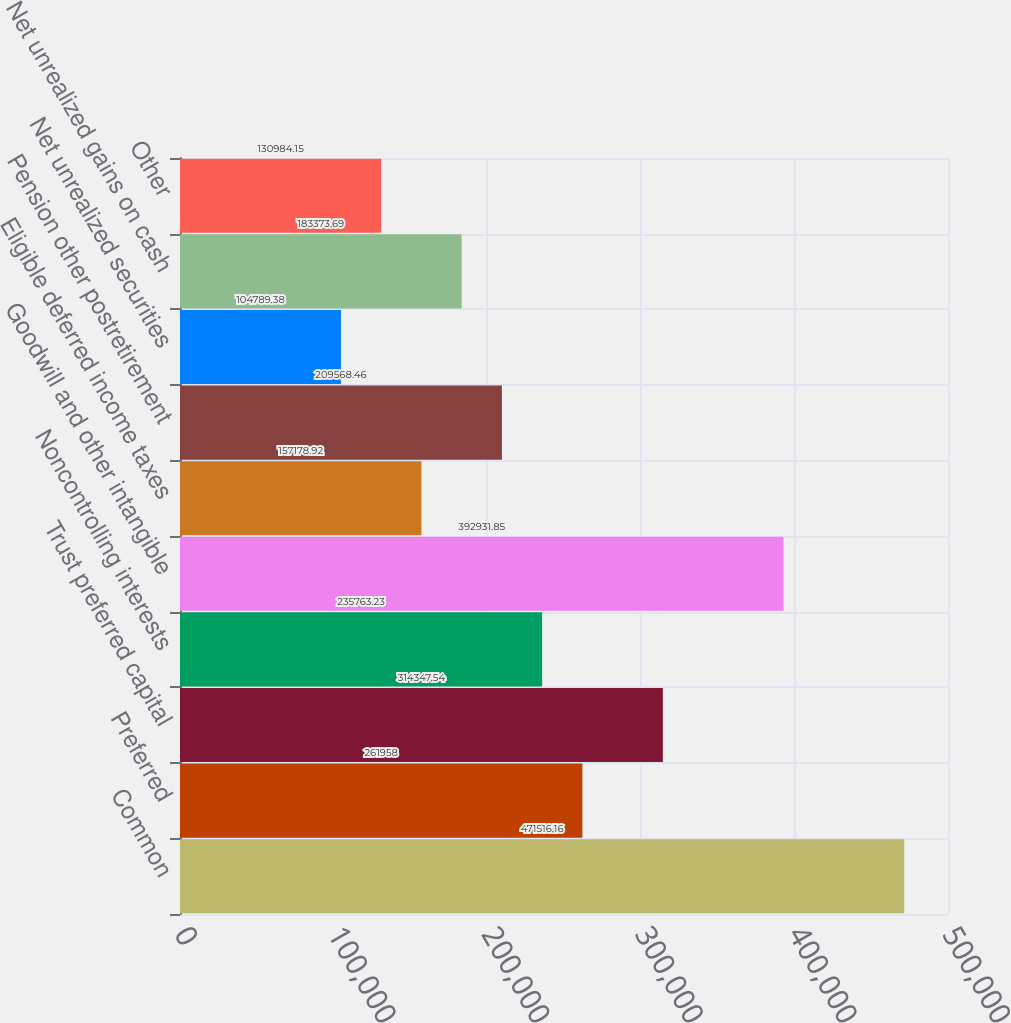<chart> <loc_0><loc_0><loc_500><loc_500><bar_chart><fcel>Common<fcel>Preferred<fcel>Trust preferred capital<fcel>Noncontrolling interests<fcel>Goodwill and other intangible<fcel>Eligible deferred income taxes<fcel>Pension other postretirement<fcel>Net unrealized securities<fcel>Net unrealized gains on cash<fcel>Other<nl><fcel>471516<fcel>261958<fcel>314348<fcel>235763<fcel>392932<fcel>157179<fcel>209568<fcel>104789<fcel>183374<fcel>130984<nl></chart> 